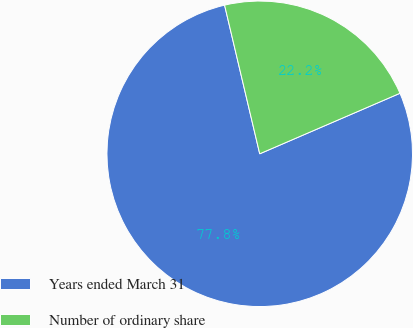Convert chart to OTSL. <chart><loc_0><loc_0><loc_500><loc_500><pie_chart><fcel>Years ended March 31<fcel>Number of ordinary share<nl><fcel>77.79%<fcel>22.21%<nl></chart> 